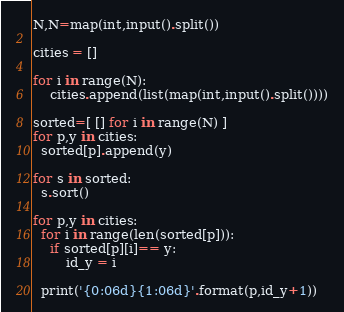<code> <loc_0><loc_0><loc_500><loc_500><_Python_>N,N=map(int,input().split())

cities = []

for i in range(N):
    cities.append(list(map(int,input().split())))

sorted=[ [] for i in range(N) ]
for p,y in cities:
  sorted[p].append(y)

for s in sorted:
  s.sort()

for p,y in cities:
  for i in range(len(sorted[p])):
    if sorted[p][i]== y:
        id_y = i

  print('{0:06d}{1:06d}'.format(p,id_y+1))

</code> 